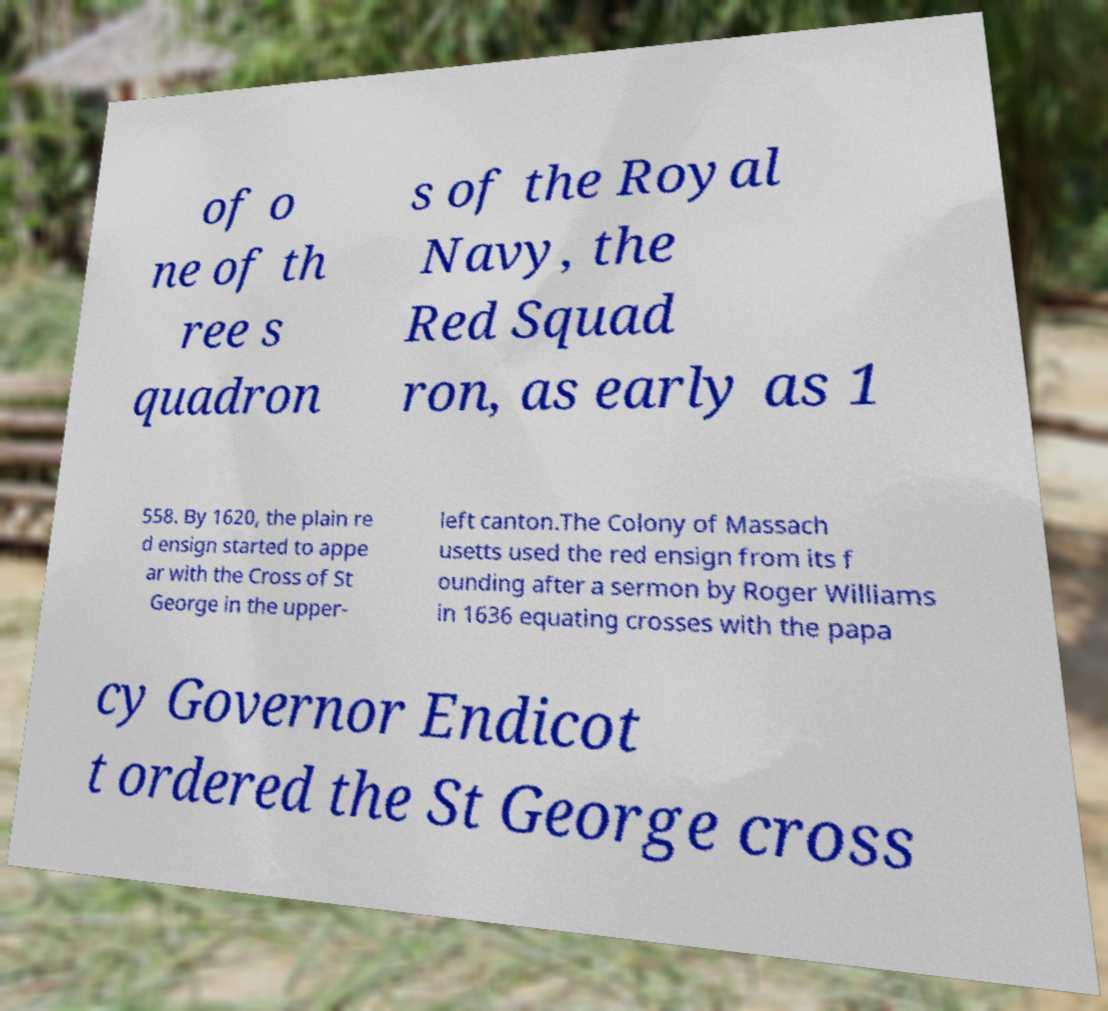Please read and relay the text visible in this image. What does it say? of o ne of th ree s quadron s of the Royal Navy, the Red Squad ron, as early as 1 558. By 1620, the plain re d ensign started to appe ar with the Cross of St George in the upper- left canton.The Colony of Massach usetts used the red ensign from its f ounding after a sermon by Roger Williams in 1636 equating crosses with the papa cy Governor Endicot t ordered the St George cross 